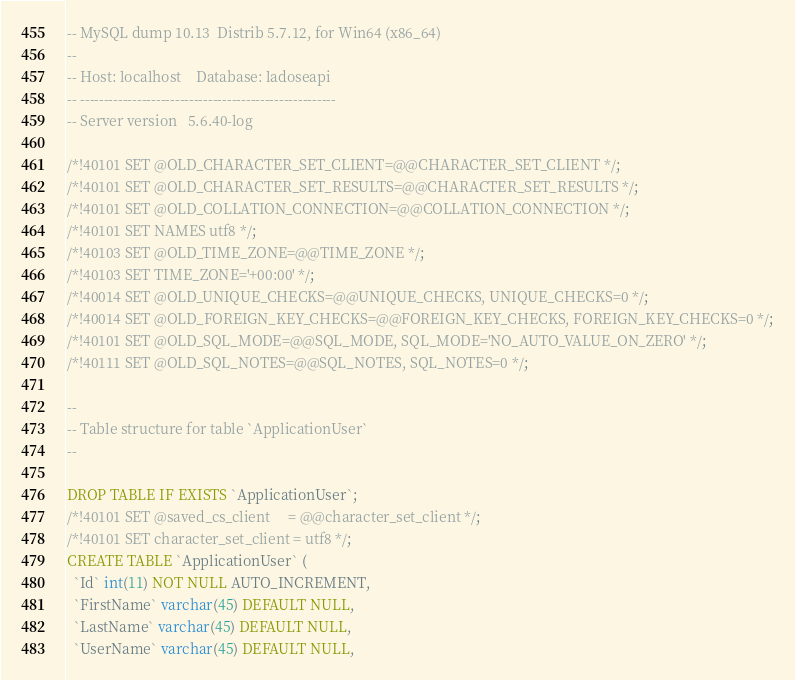Convert code to text. <code><loc_0><loc_0><loc_500><loc_500><_SQL_>-- MySQL dump 10.13  Distrib 5.7.12, for Win64 (x86_64)
--
-- Host: localhost    Database: ladoseapi
-- ------------------------------------------------------
-- Server version	5.6.40-log

/*!40101 SET @OLD_CHARACTER_SET_CLIENT=@@CHARACTER_SET_CLIENT */;
/*!40101 SET @OLD_CHARACTER_SET_RESULTS=@@CHARACTER_SET_RESULTS */;
/*!40101 SET @OLD_COLLATION_CONNECTION=@@COLLATION_CONNECTION */;
/*!40101 SET NAMES utf8 */;
/*!40103 SET @OLD_TIME_ZONE=@@TIME_ZONE */;
/*!40103 SET TIME_ZONE='+00:00' */;
/*!40014 SET @OLD_UNIQUE_CHECKS=@@UNIQUE_CHECKS, UNIQUE_CHECKS=0 */;
/*!40014 SET @OLD_FOREIGN_KEY_CHECKS=@@FOREIGN_KEY_CHECKS, FOREIGN_KEY_CHECKS=0 */;
/*!40101 SET @OLD_SQL_MODE=@@SQL_MODE, SQL_MODE='NO_AUTO_VALUE_ON_ZERO' */;
/*!40111 SET @OLD_SQL_NOTES=@@SQL_NOTES, SQL_NOTES=0 */;

--
-- Table structure for table `ApplicationUser`
--

DROP TABLE IF EXISTS `ApplicationUser`;
/*!40101 SET @saved_cs_client     = @@character_set_client */;
/*!40101 SET character_set_client = utf8 */;
CREATE TABLE `ApplicationUser` (
  `Id` int(11) NOT NULL AUTO_INCREMENT,
  `FirstName` varchar(45) DEFAULT NULL,
  `LastName` varchar(45) DEFAULT NULL,
  `UserName` varchar(45) DEFAULT NULL,</code> 